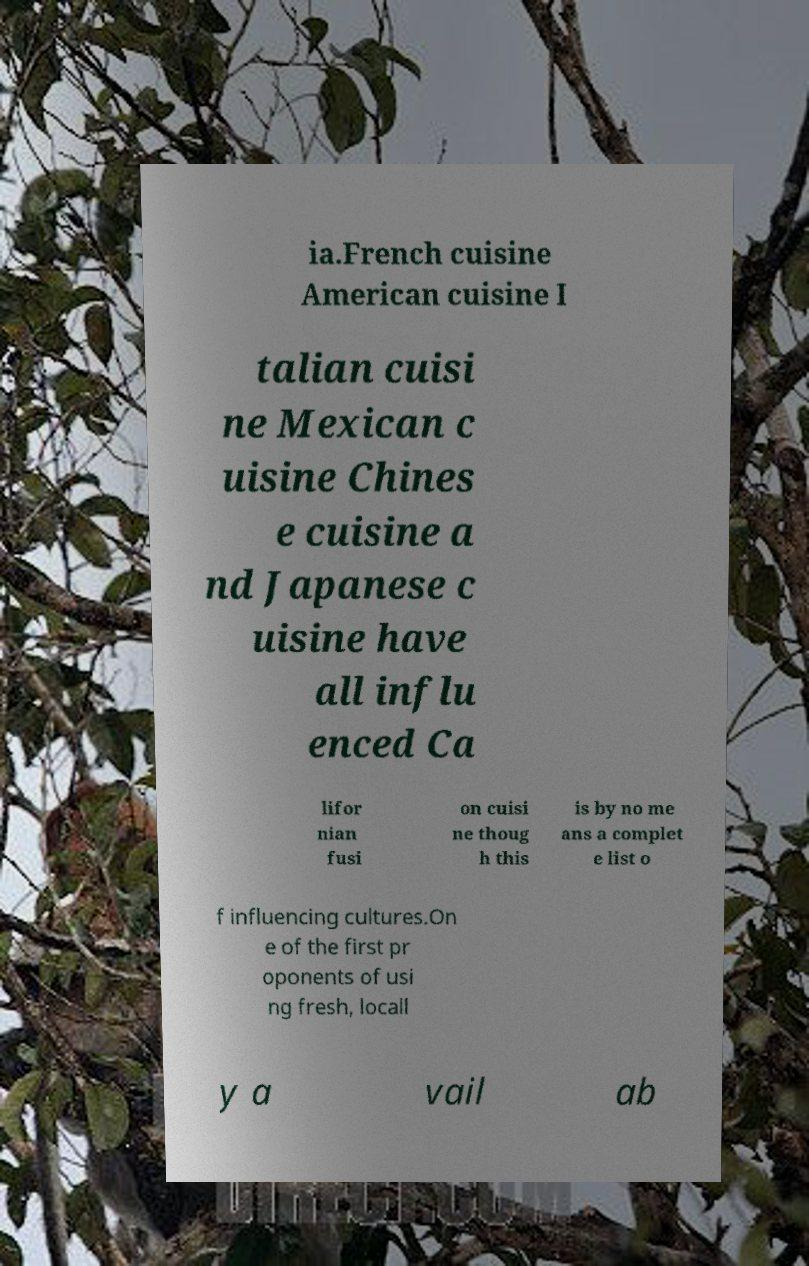For documentation purposes, I need the text within this image transcribed. Could you provide that? ia.French cuisine American cuisine I talian cuisi ne Mexican c uisine Chines e cuisine a nd Japanese c uisine have all influ enced Ca lifor nian fusi on cuisi ne thoug h this is by no me ans a complet e list o f influencing cultures.On e of the first pr oponents of usi ng fresh, locall y a vail ab 